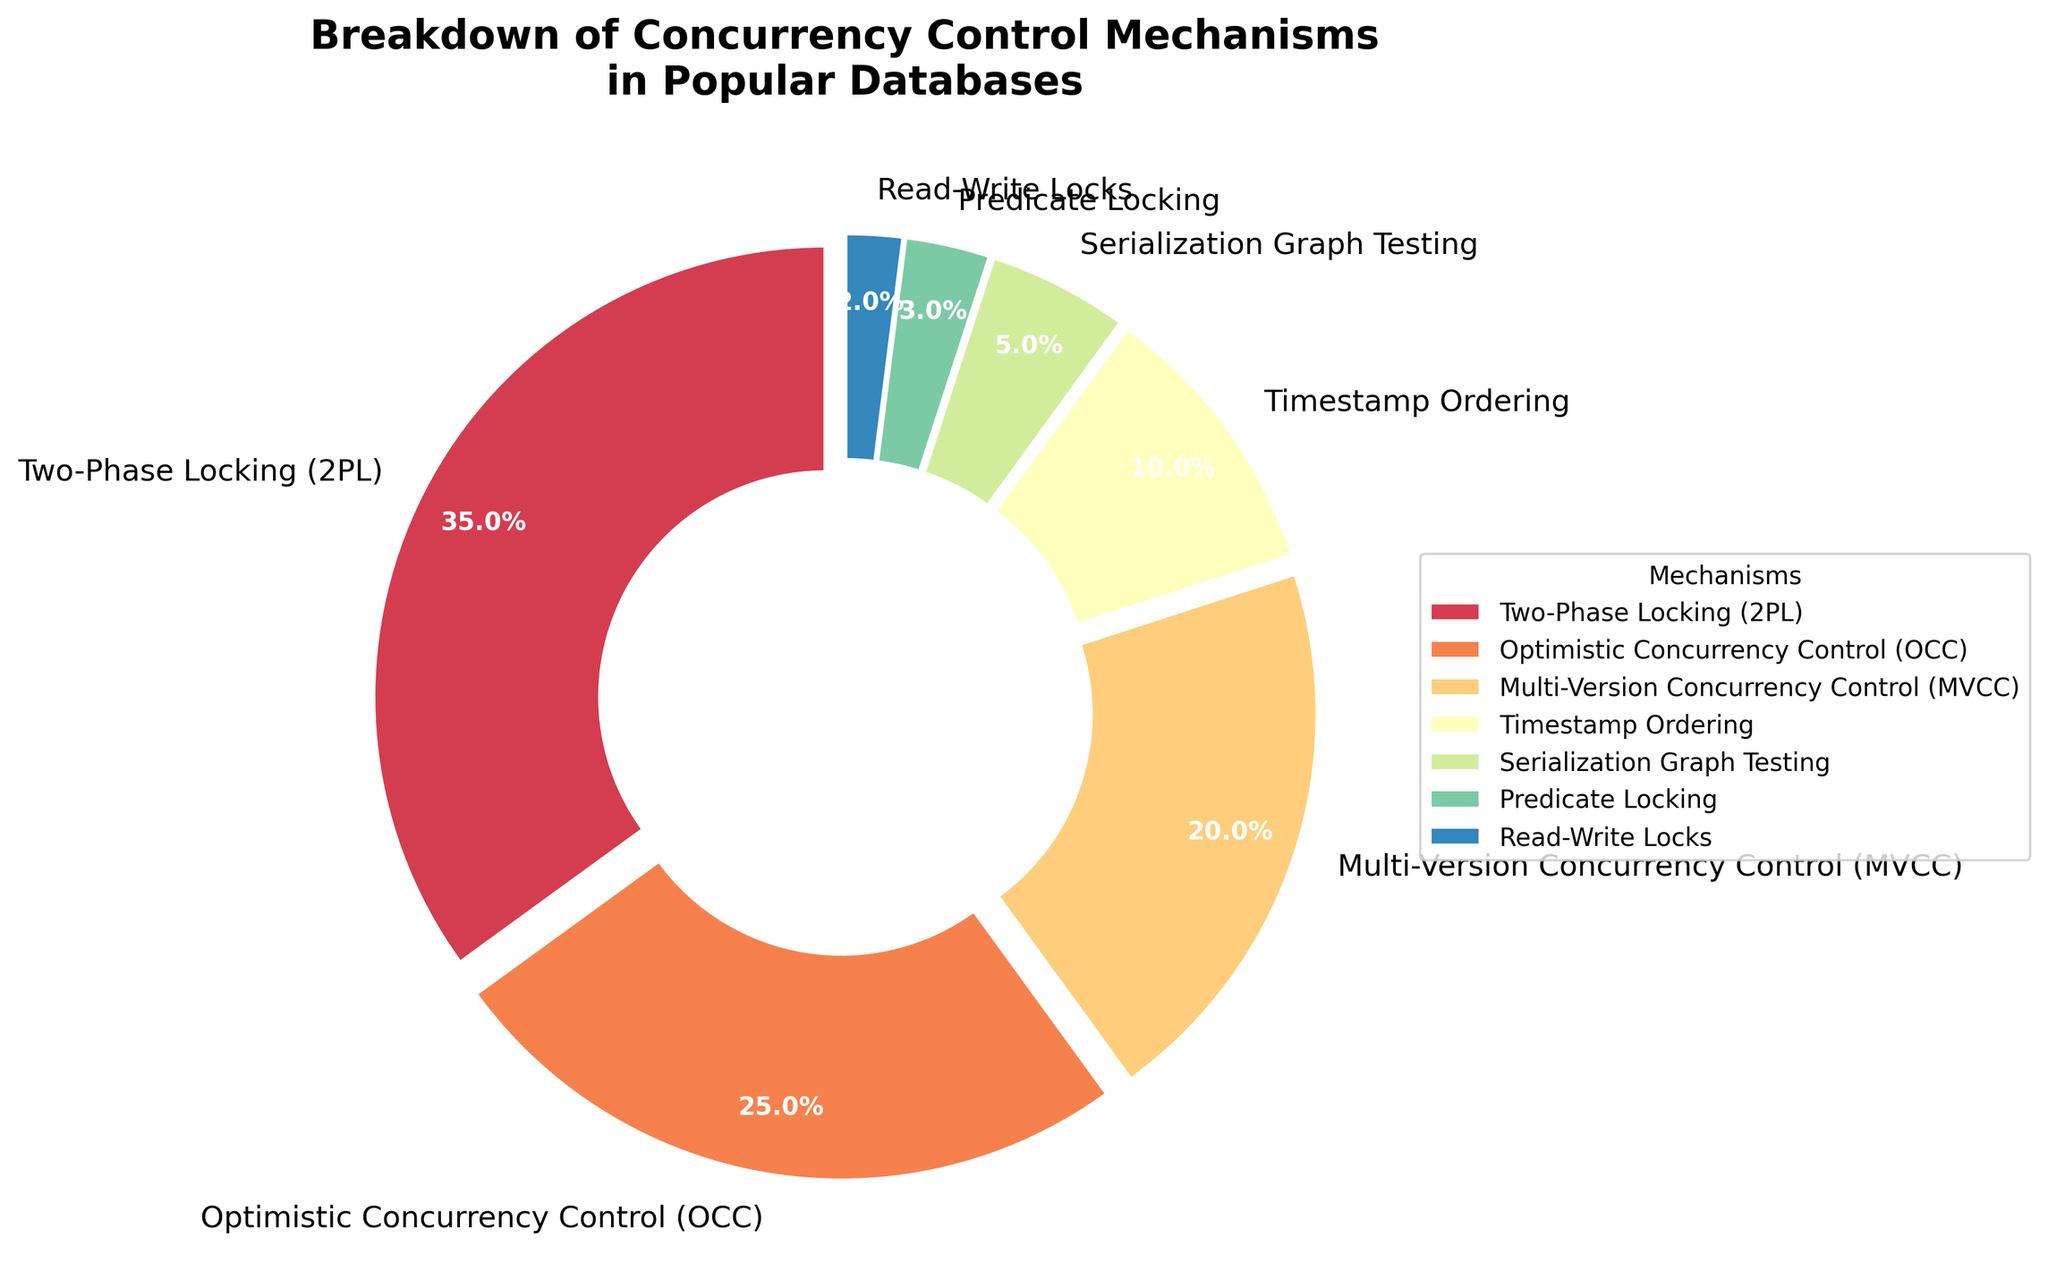What's the most common concurrency control mechanism in popular databases? The slice representing Two-Phase Locking (2PL) occupies the largest part of the pie chart. It is the highest percentage at 35%.
Answer: Two-Phase Locking (2PL) Among Optimistic Concurrency Control (OCC) and Multi-Version Concurrency Control (MVCC), which has a higher percentage and by how much? By observing the chart, OCC is 25% and MVCC is 20%. The difference is 25% - 20% = 5%. So, OCC has a higher percentage by 5%.
Answer: OCC by 5% Which concurrency control mechanisms together constitute 45% of the total mechanisms in the chart? By adding the percentages of Timestamp Ordering (10%), Serialization Graph Testing (5%), Predicate Locking (3%), and Read-Write Locks (2%), the total is 10% + 5% + 3% + 2% = 20%. By adding MVCC's 20% and OCC's 25%, we get 45%. Hence, MVCC and OCC together account for 45%.
Answer: MVCC and OCC What's the percentage difference between the least and the most common concurrency control mechanisms? The least common mechanism is Read-Write Locks at 2%, and the most common is Two-Phase Locking (2PL) at 35%. The difference is 35% - 2% = 33%.
Answer: 33% What's the combined percentage of all mechanisms except Two-Phase Locking (2PL) and OCC? Adding the remaining mechanisms: MVCC (20%), Timestamp Ordering (10%), Serialization Graph Testing (5%), Predicate Locking (3%), and Read-Write Locks (2%). The total is 20% + 10% + 5% + 3% + 2% = 40%.
Answer: 40% Which mechanisms are represented by colors closer to the center of the circular spectrum? The pie chart uses a spectral color map. Typically, central colors in such a map would be found in the middle of the percentage range. MVCC (20%) and Timestamp Ordering (10%) share these positions and have colors closer to the center of the spectrum.
Answer: MVCC and Timestamp Ordering How many mechanisms have percentages above 10%? Observing the chart, Two-Phase Locking (35%), Optimistic Concurrency Control (25%), and Multi-Version Concurrency Control (20%) are all above 10%. Hence, there are three such mechanisms.
Answer: Three mechanisms What's the average percentage of Multi-Version Concurrency Control (MVCC), Timestamp Ordering, and Serialization Graph Testing? Adding the percentages MVCC (20%), Timestamp Ordering (10%), and Serialization Graph Testing (5%) gives 20% + 10% + 5% = 35%. The average is 35% / 3 = 11.67%.
Answer: 11.67% 